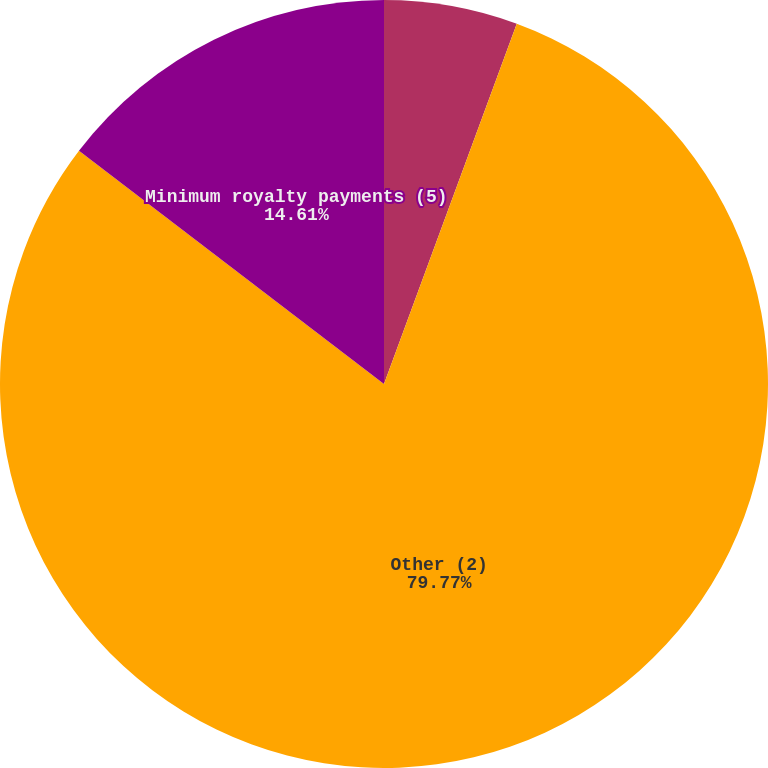<chart> <loc_0><loc_0><loc_500><loc_500><pie_chart><fcel>Long-term debt (1)<fcel>Other (2)<fcel>Minimum royalty payments (5)<nl><fcel>5.62%<fcel>79.78%<fcel>14.61%<nl></chart> 